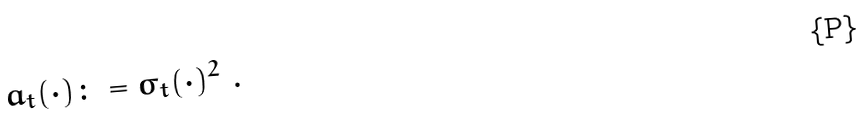Convert formula to latex. <formula><loc_0><loc_0><loc_500><loc_500>a _ { t } ( \cdot ) \colon = \sigma _ { t } ( \cdot ) ^ { 2 } \ .</formula> 